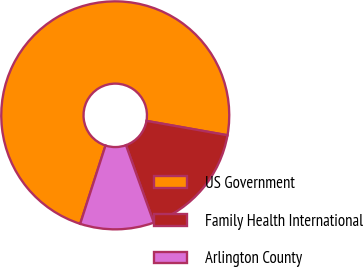Convert chart. <chart><loc_0><loc_0><loc_500><loc_500><pie_chart><fcel>US Government<fcel>Family Health International<fcel>Arlington County<nl><fcel>72.82%<fcel>16.71%<fcel>10.47%<nl></chart> 